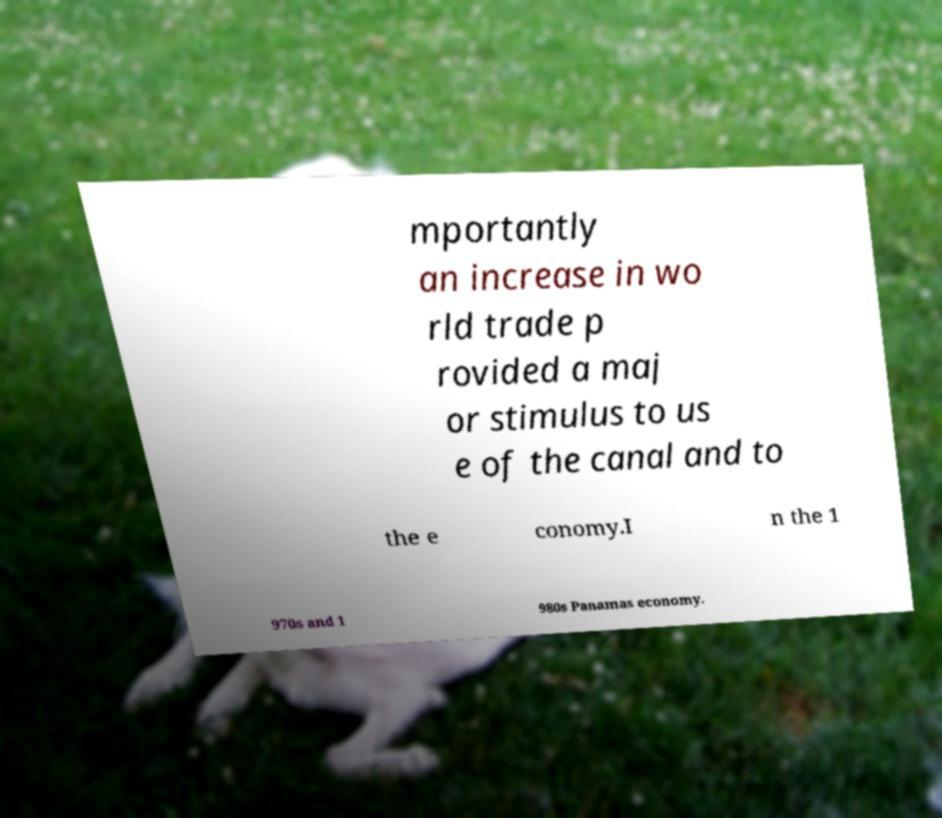I need the written content from this picture converted into text. Can you do that? mportantly an increase in wo rld trade p rovided a maj or stimulus to us e of the canal and to the e conomy.I n the 1 970s and 1 980s Panamas economy. 